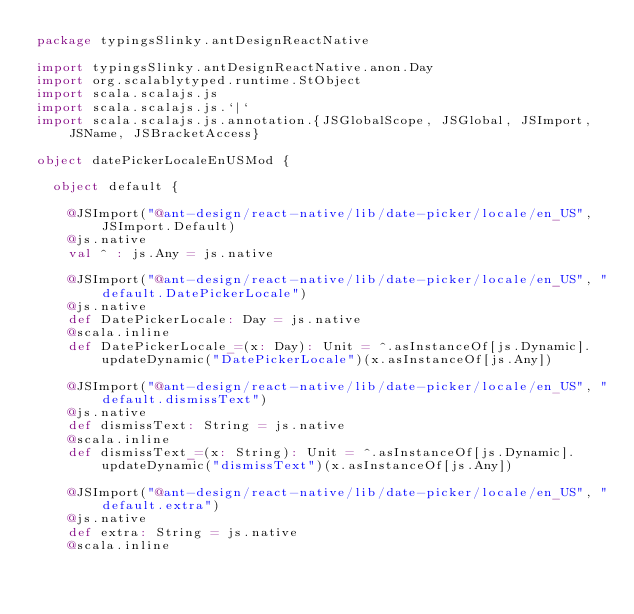<code> <loc_0><loc_0><loc_500><loc_500><_Scala_>package typingsSlinky.antDesignReactNative

import typingsSlinky.antDesignReactNative.anon.Day
import org.scalablytyped.runtime.StObject
import scala.scalajs.js
import scala.scalajs.js.`|`
import scala.scalajs.js.annotation.{JSGlobalScope, JSGlobal, JSImport, JSName, JSBracketAccess}

object datePickerLocaleEnUSMod {
  
  object default {
    
    @JSImport("@ant-design/react-native/lib/date-picker/locale/en_US", JSImport.Default)
    @js.native
    val ^ : js.Any = js.native
    
    @JSImport("@ant-design/react-native/lib/date-picker/locale/en_US", "default.DatePickerLocale")
    @js.native
    def DatePickerLocale: Day = js.native
    @scala.inline
    def DatePickerLocale_=(x: Day): Unit = ^.asInstanceOf[js.Dynamic].updateDynamic("DatePickerLocale")(x.asInstanceOf[js.Any])
    
    @JSImport("@ant-design/react-native/lib/date-picker/locale/en_US", "default.dismissText")
    @js.native
    def dismissText: String = js.native
    @scala.inline
    def dismissText_=(x: String): Unit = ^.asInstanceOf[js.Dynamic].updateDynamic("dismissText")(x.asInstanceOf[js.Any])
    
    @JSImport("@ant-design/react-native/lib/date-picker/locale/en_US", "default.extra")
    @js.native
    def extra: String = js.native
    @scala.inline</code> 